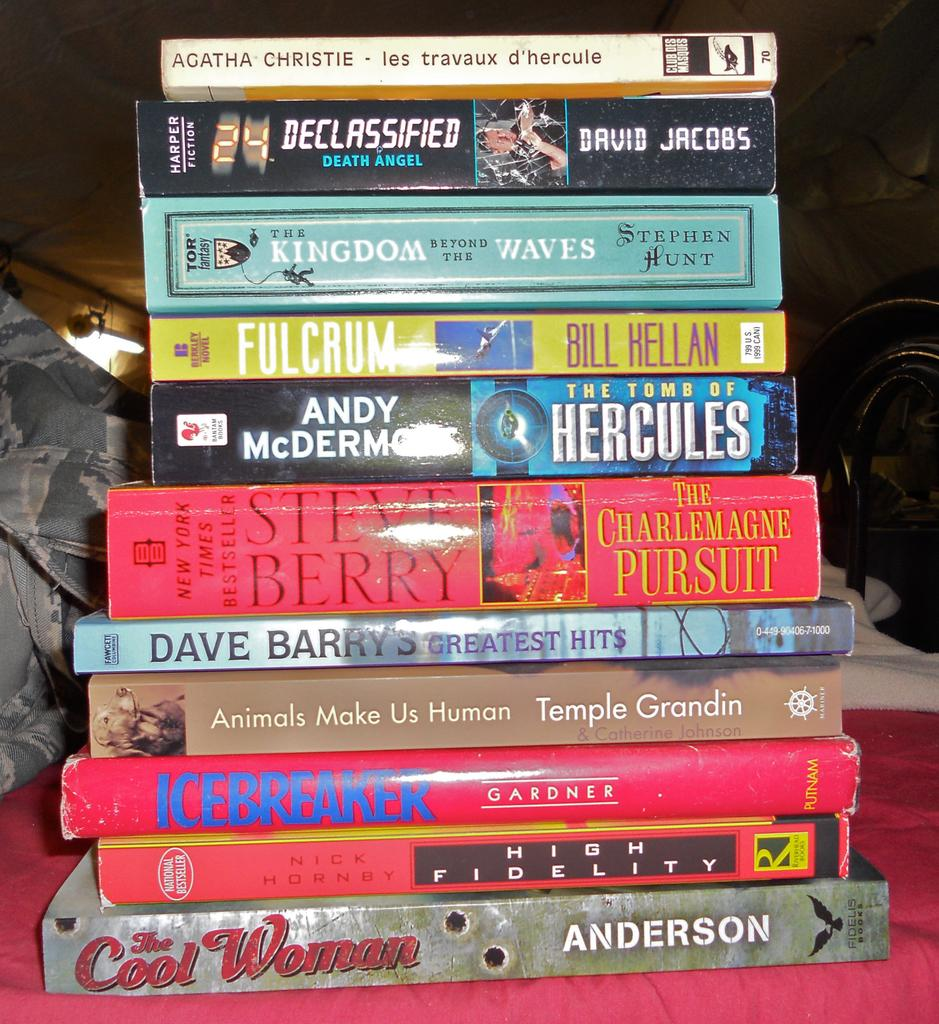<image>
Offer a succinct explanation of the picture presented. A stack of books including one by Agatha Christie and David Jacobs. 